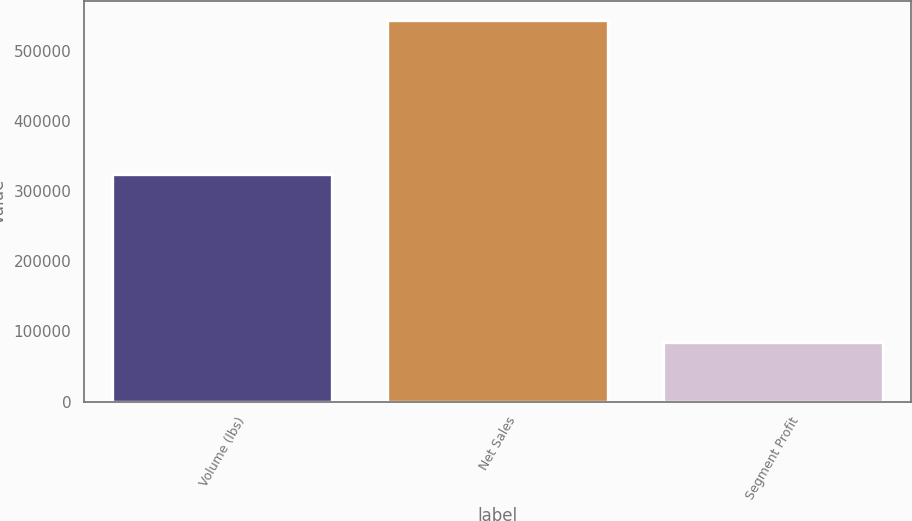<chart> <loc_0><loc_0><loc_500><loc_500><bar_chart><fcel>Volume (lbs)<fcel>Net Sales<fcel>Segment Profit<nl><fcel>324895<fcel>545014<fcel>85304<nl></chart> 